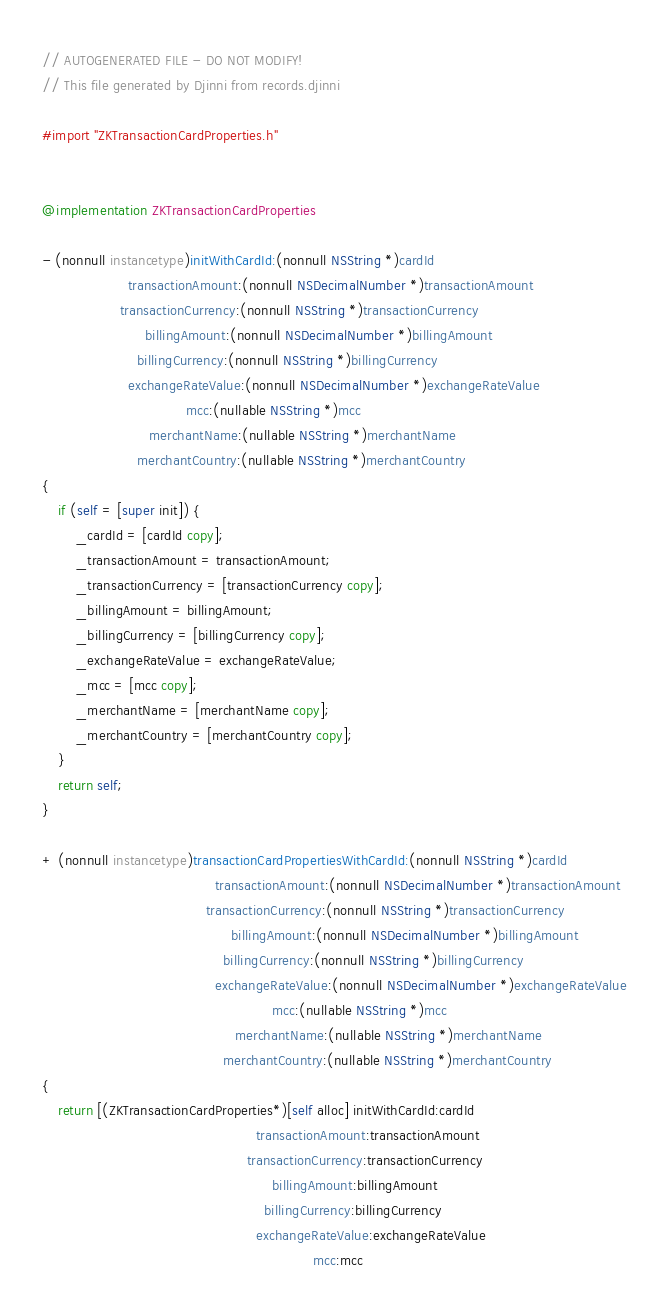Convert code to text. <code><loc_0><loc_0><loc_500><loc_500><_ObjectiveC_>// AUTOGENERATED FILE - DO NOT MODIFY!
// This file generated by Djinni from records.djinni

#import "ZKTransactionCardProperties.h"


@implementation ZKTransactionCardProperties

- (nonnull instancetype)initWithCardId:(nonnull NSString *)cardId
                     transactionAmount:(nonnull NSDecimalNumber *)transactionAmount
                   transactionCurrency:(nonnull NSString *)transactionCurrency
                         billingAmount:(nonnull NSDecimalNumber *)billingAmount
                       billingCurrency:(nonnull NSString *)billingCurrency
                     exchangeRateValue:(nonnull NSDecimalNumber *)exchangeRateValue
                                   mcc:(nullable NSString *)mcc
                          merchantName:(nullable NSString *)merchantName
                       merchantCountry:(nullable NSString *)merchantCountry
{
    if (self = [super init]) {
        _cardId = [cardId copy];
        _transactionAmount = transactionAmount;
        _transactionCurrency = [transactionCurrency copy];
        _billingAmount = billingAmount;
        _billingCurrency = [billingCurrency copy];
        _exchangeRateValue = exchangeRateValue;
        _mcc = [mcc copy];
        _merchantName = [merchantName copy];
        _merchantCountry = [merchantCountry copy];
    }
    return self;
}

+ (nonnull instancetype)transactionCardPropertiesWithCardId:(nonnull NSString *)cardId
                                          transactionAmount:(nonnull NSDecimalNumber *)transactionAmount
                                        transactionCurrency:(nonnull NSString *)transactionCurrency
                                              billingAmount:(nonnull NSDecimalNumber *)billingAmount
                                            billingCurrency:(nonnull NSString *)billingCurrency
                                          exchangeRateValue:(nonnull NSDecimalNumber *)exchangeRateValue
                                                        mcc:(nullable NSString *)mcc
                                               merchantName:(nullable NSString *)merchantName
                                            merchantCountry:(nullable NSString *)merchantCountry
{
    return [(ZKTransactionCardProperties*)[self alloc] initWithCardId:cardId
                                                    transactionAmount:transactionAmount
                                                  transactionCurrency:transactionCurrency
                                                        billingAmount:billingAmount
                                                      billingCurrency:billingCurrency
                                                    exchangeRateValue:exchangeRateValue
                                                                  mcc:mcc</code> 